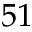<formula> <loc_0><loc_0><loc_500><loc_500>5 1</formula> 